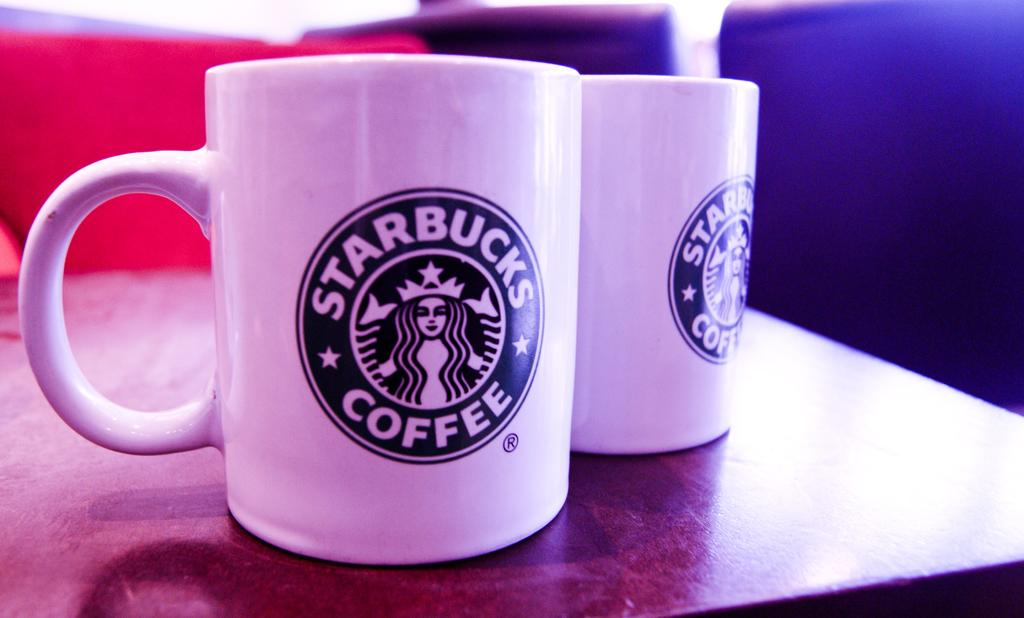What color are the mugs in the image? The mugs in the image are white. Where are the mugs located? The mugs are on a table. What is written or printed on the mugs? There is text on the mugs. What furniture is present near the table? There are two chairs beside the table. How does the pig express hope in the image? There is no pig present in the image, and therefore no such expression of hope can be observed. 